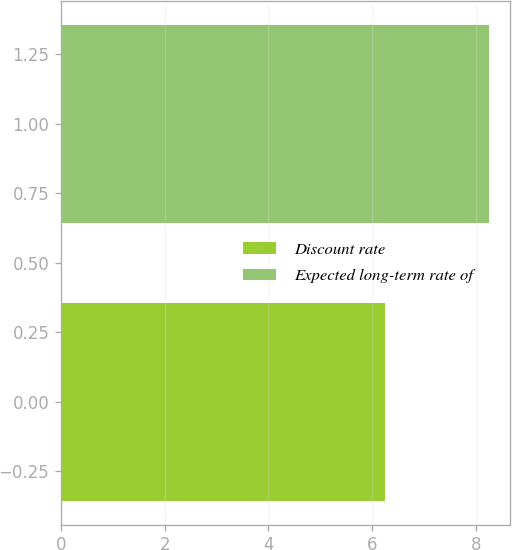Convert chart to OTSL. <chart><loc_0><loc_0><loc_500><loc_500><bar_chart><fcel>Discount rate<fcel>Expected long-term rate of<nl><fcel>6.25<fcel>8.25<nl></chart> 